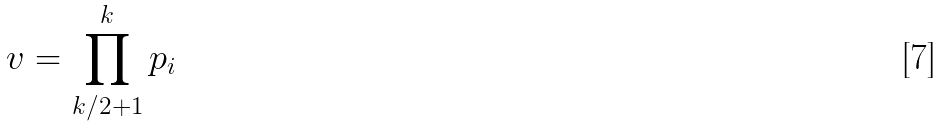Convert formula to latex. <formula><loc_0><loc_0><loc_500><loc_500>v = \prod _ { k / 2 + 1 } ^ { k } p _ { i }</formula> 